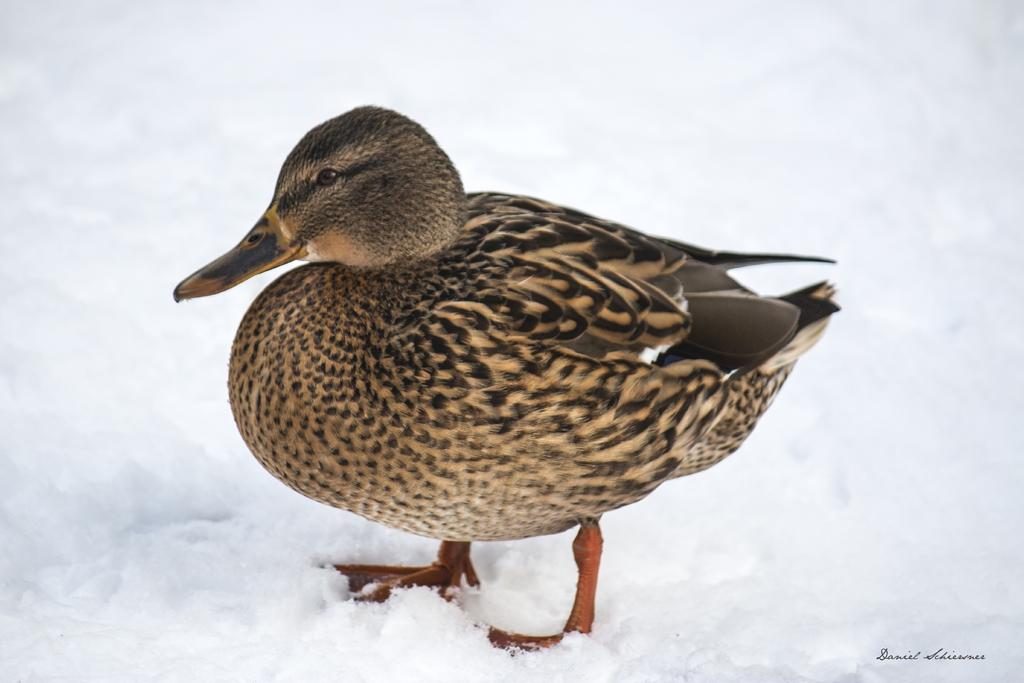What type of animal is in the image? There is a bird in the image. What color is the bird? The bird is brown in color. What is the bird standing on? The bird is standing on snow. What color is the snow? The snow is white in color. What decision does the bird make about the pan in the image? There is no pan present in the image, so the bird cannot make any decisions about it. 